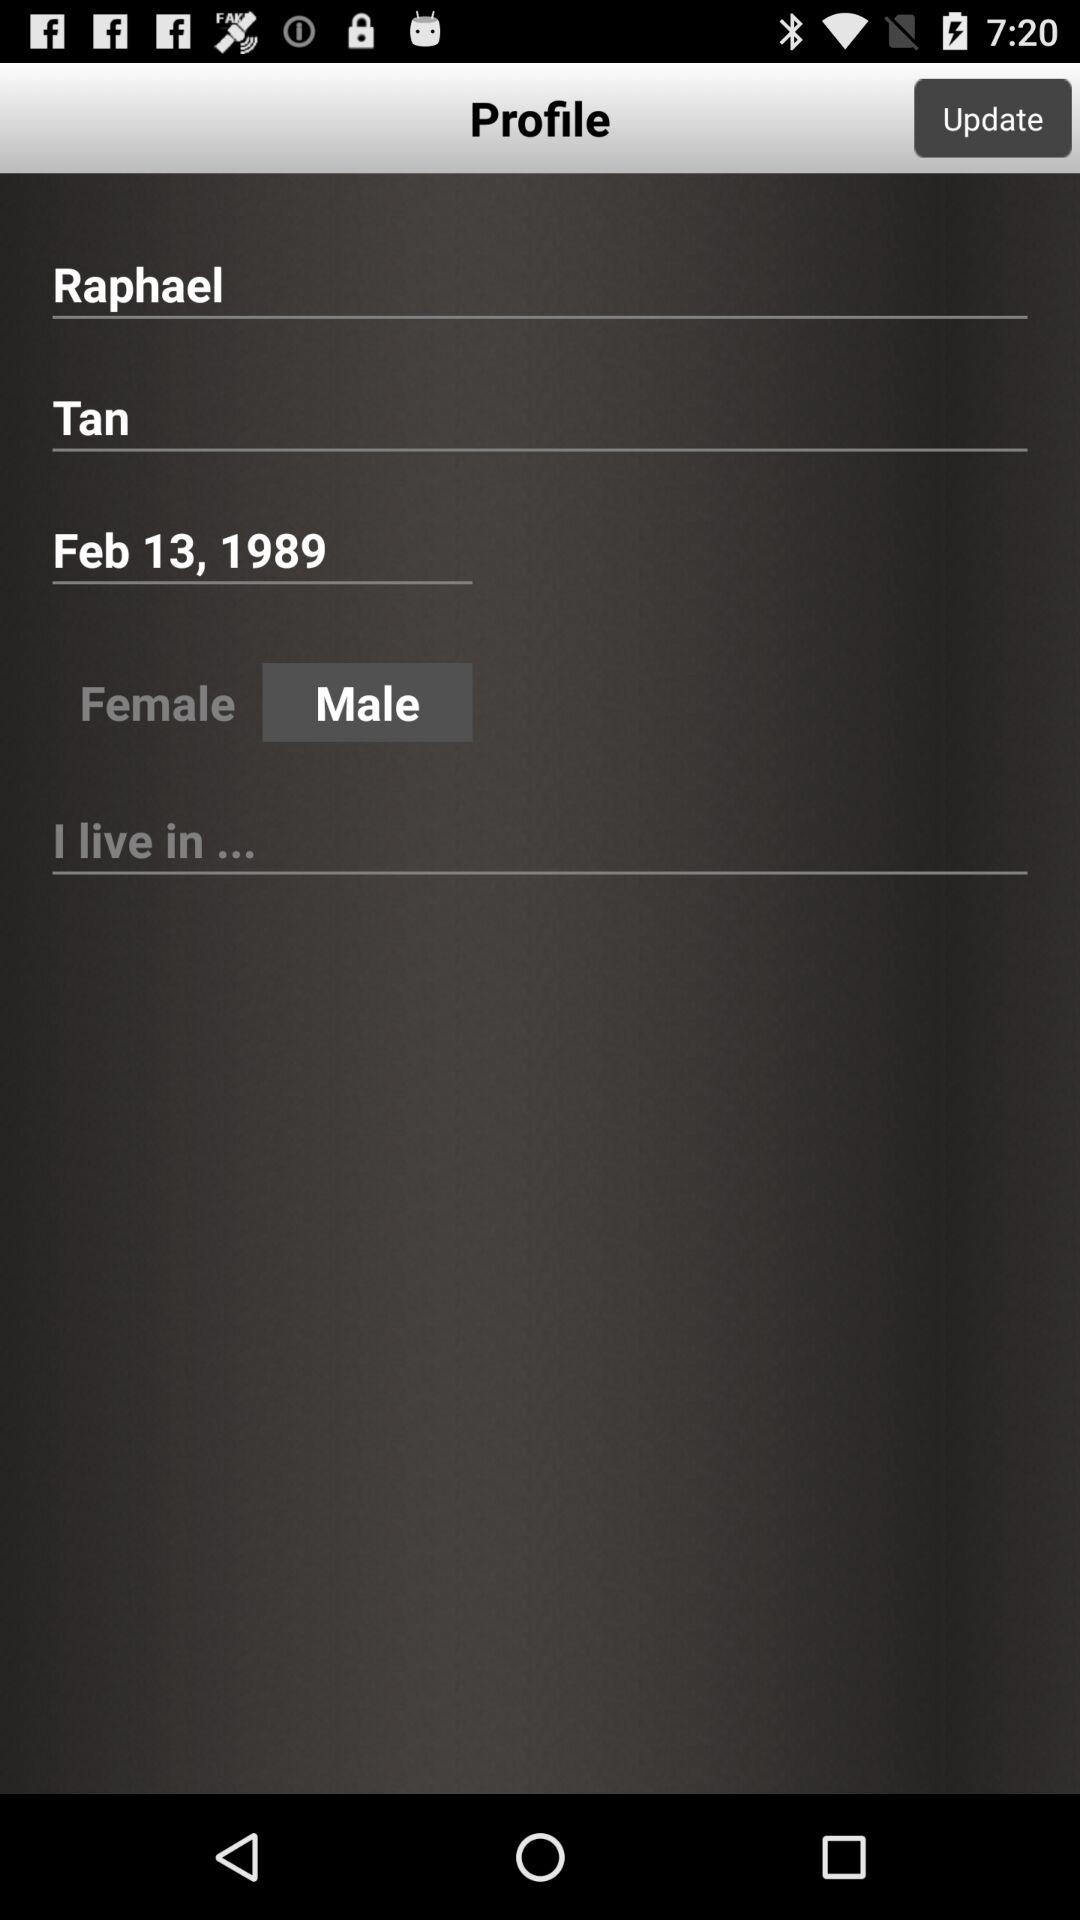What is the gender of the user? The gender of the user is male. 